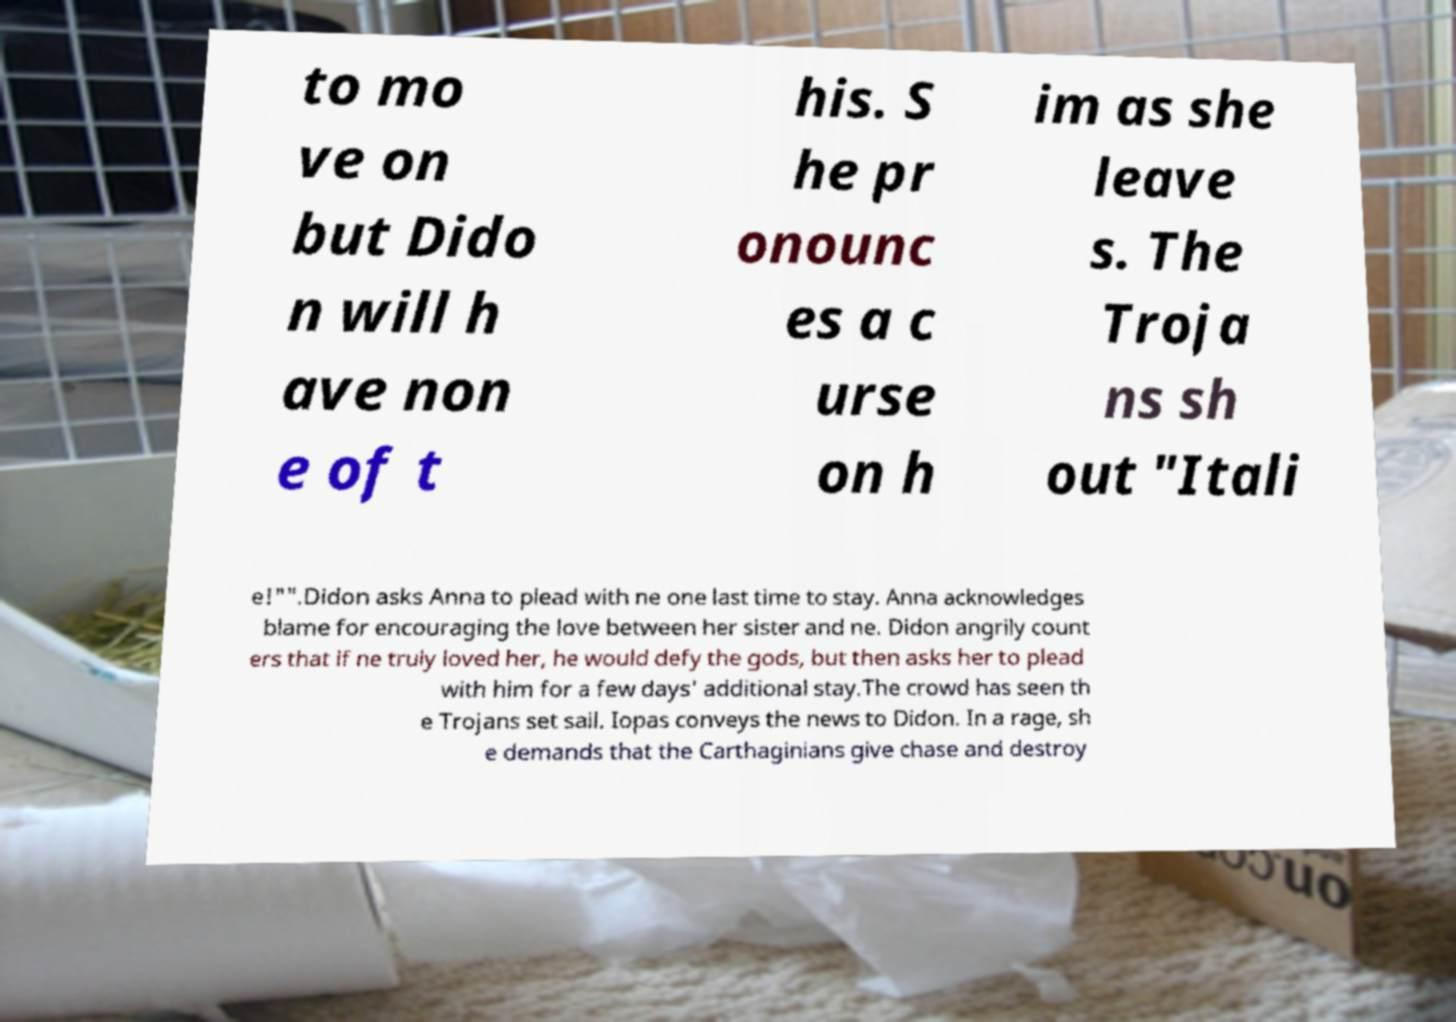What messages or text are displayed in this image? I need them in a readable, typed format. to mo ve on but Dido n will h ave non e of t his. S he pr onounc es a c urse on h im as she leave s. The Troja ns sh out "Itali e!"".Didon asks Anna to plead with ne one last time to stay. Anna acknowledges blame for encouraging the love between her sister and ne. Didon angrily count ers that if ne truly loved her, he would defy the gods, but then asks her to plead with him for a few days' additional stay.The crowd has seen th e Trojans set sail. Iopas conveys the news to Didon. In a rage, sh e demands that the Carthaginians give chase and destroy 